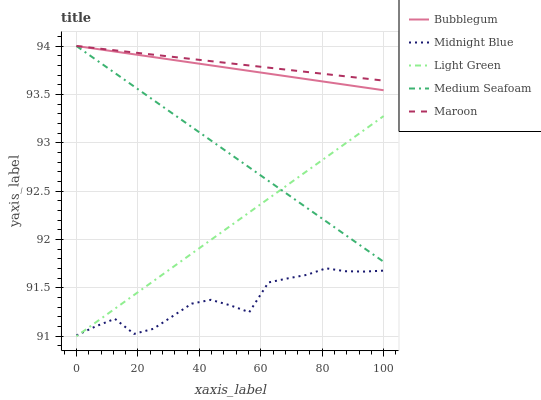Does Midnight Blue have the minimum area under the curve?
Answer yes or no. Yes. Does Maroon have the maximum area under the curve?
Answer yes or no. Yes. Does Light Green have the minimum area under the curve?
Answer yes or no. No. Does Light Green have the maximum area under the curve?
Answer yes or no. No. Is Bubblegum the smoothest?
Answer yes or no. Yes. Is Midnight Blue the roughest?
Answer yes or no. Yes. Is Light Green the smoothest?
Answer yes or no. No. Is Light Green the roughest?
Answer yes or no. No. Does Light Green have the lowest value?
Answer yes or no. Yes. Does Midnight Blue have the lowest value?
Answer yes or no. No. Does Medium Seafoam have the highest value?
Answer yes or no. Yes. Does Light Green have the highest value?
Answer yes or no. No. Is Light Green less than Maroon?
Answer yes or no. Yes. Is Maroon greater than Light Green?
Answer yes or no. Yes. Does Light Green intersect Medium Seafoam?
Answer yes or no. Yes. Is Light Green less than Medium Seafoam?
Answer yes or no. No. Is Light Green greater than Medium Seafoam?
Answer yes or no. No. Does Light Green intersect Maroon?
Answer yes or no. No. 